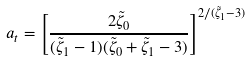<formula> <loc_0><loc_0><loc_500><loc_500>a _ { t } = \left [ \frac { 2 \tilde { \zeta } _ { 0 } } { ( \tilde { \zeta } _ { 1 } - 1 ) ( \tilde { \zeta } _ { 0 } + \tilde { \zeta } _ { 1 } - 3 ) } \right ] ^ { 2 / ( \tilde { \zeta } _ { 1 } - 3 ) }</formula> 